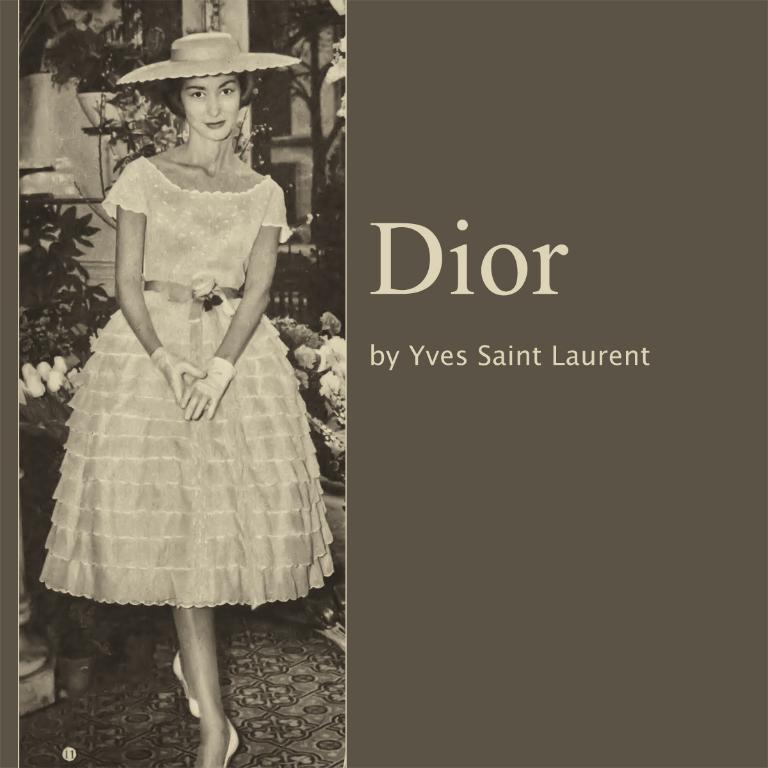<image>
Present a compact description of the photo's key features. The brand of product here is by a company called Dior 